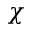<formula> <loc_0><loc_0><loc_500><loc_500>\chi</formula> 